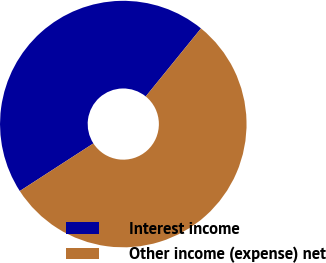Convert chart. <chart><loc_0><loc_0><loc_500><loc_500><pie_chart><fcel>Interest income<fcel>Other income (expense) net<nl><fcel>45.0%<fcel>55.0%<nl></chart> 